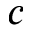<formula> <loc_0><loc_0><loc_500><loc_500>c</formula> 